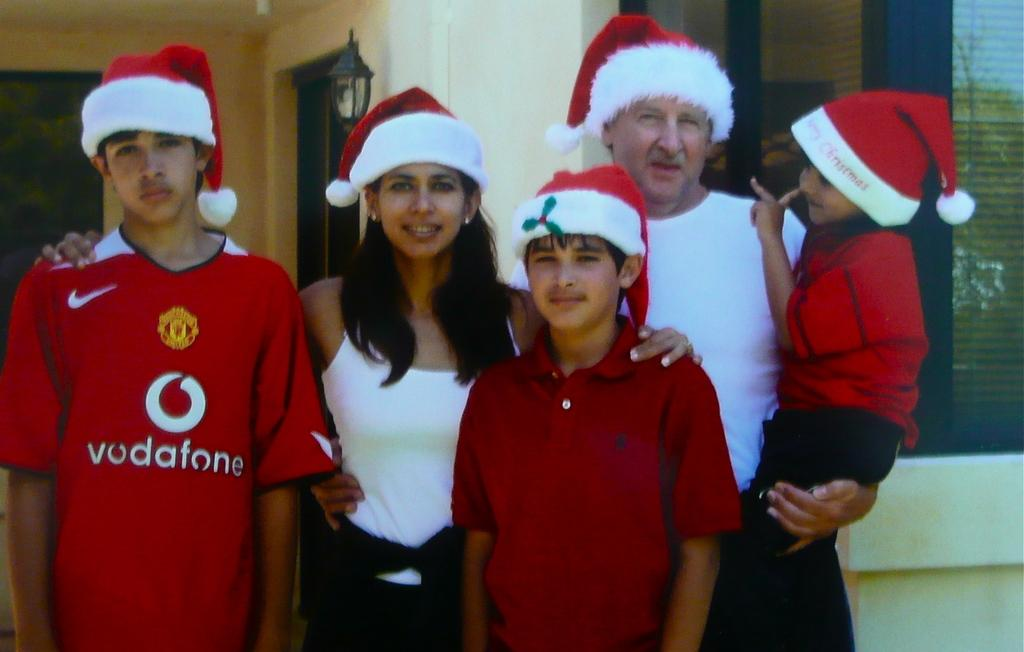<image>
Write a terse but informative summary of the picture. a boy that has the name vudafone on his shirt 